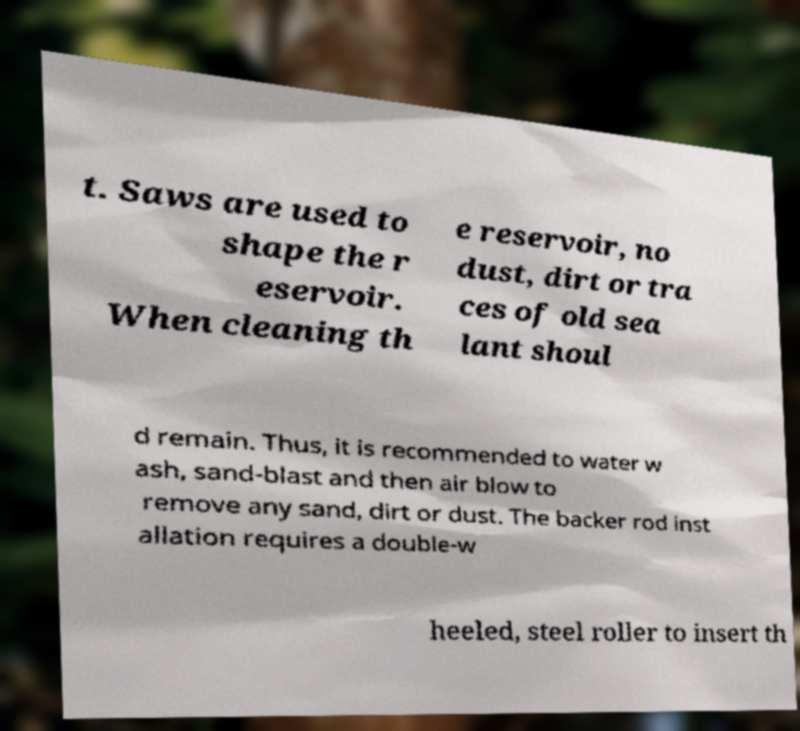Could you assist in decoding the text presented in this image and type it out clearly? t. Saws are used to shape the r eservoir. When cleaning th e reservoir, no dust, dirt or tra ces of old sea lant shoul d remain. Thus, it is recommended to water w ash, sand-blast and then air blow to remove any sand, dirt or dust. The backer rod inst allation requires a double-w heeled, steel roller to insert th 